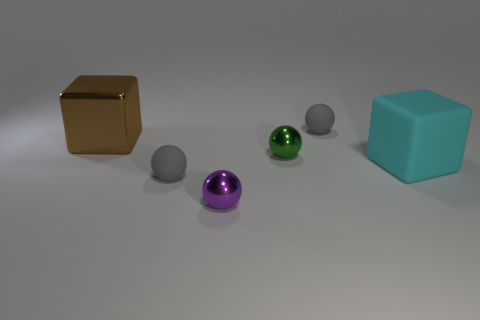Subtract all purple cylinders. How many gray spheres are left? 2 Subtract all green spheres. How many spheres are left? 3 Subtract 1 spheres. How many spheres are left? 3 Subtract all purple balls. How many balls are left? 3 Add 1 big brown blocks. How many objects exist? 7 Subtract all red spheres. Subtract all cyan cylinders. How many spheres are left? 4 Subtract all cubes. How many objects are left? 4 Add 6 big metal cubes. How many big metal cubes are left? 7 Add 4 big metal objects. How many big metal objects exist? 5 Subtract 0 blue balls. How many objects are left? 6 